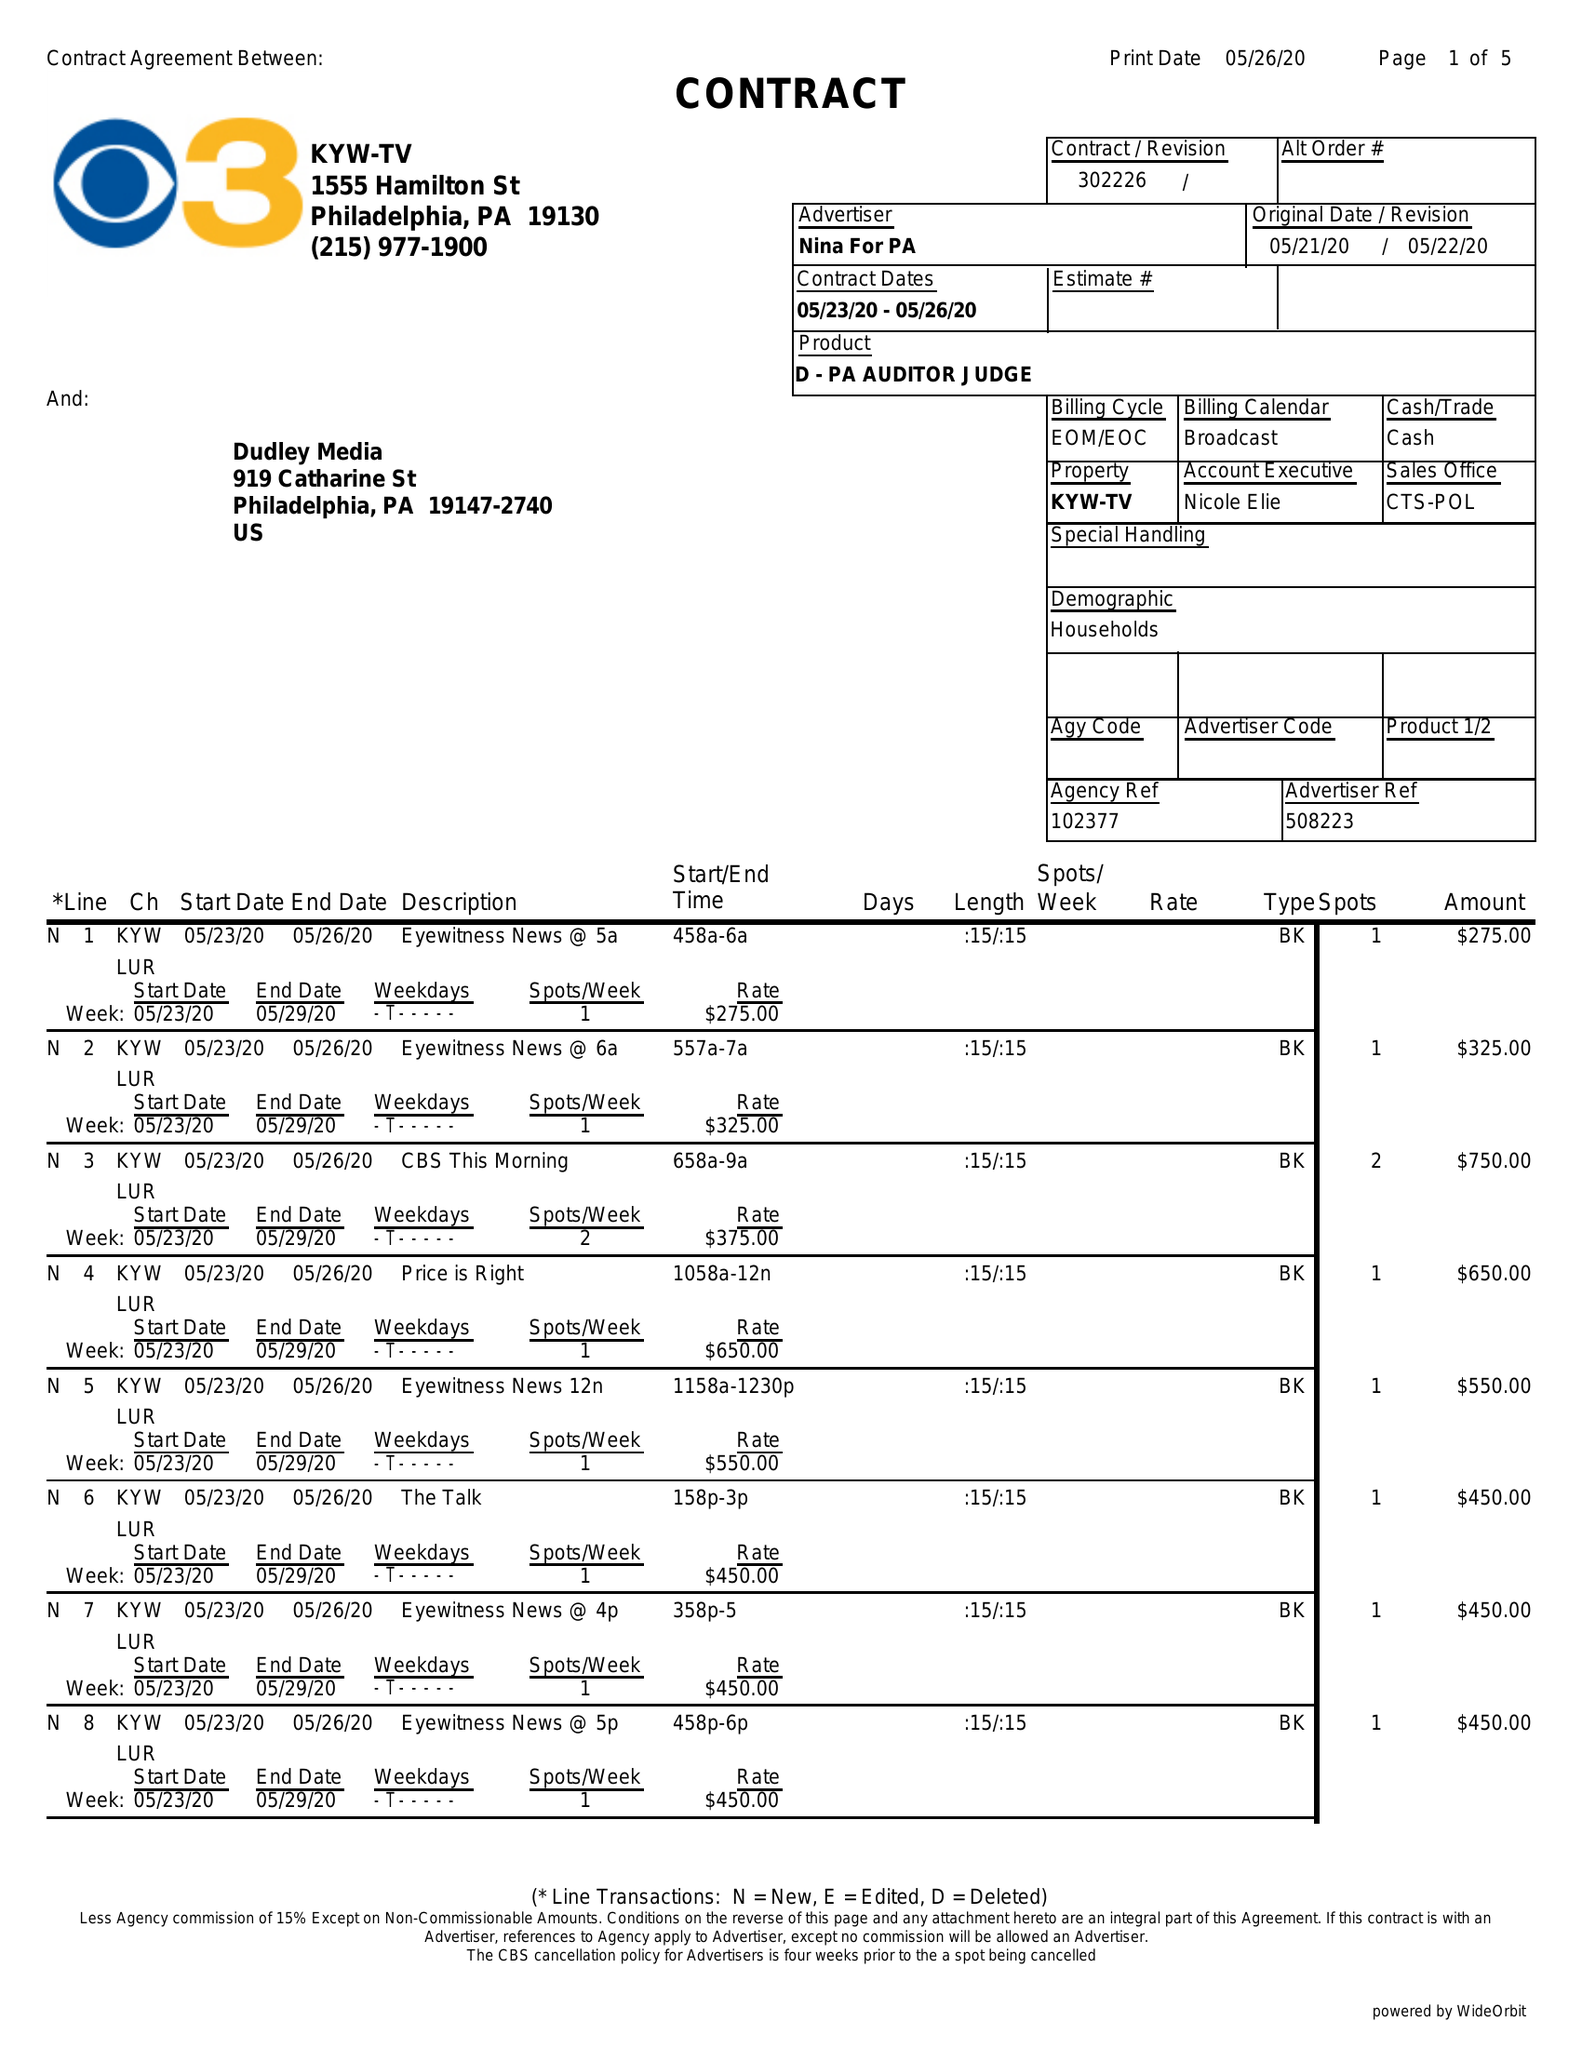What is the value for the flight_from?
Answer the question using a single word or phrase. 05/23/20 